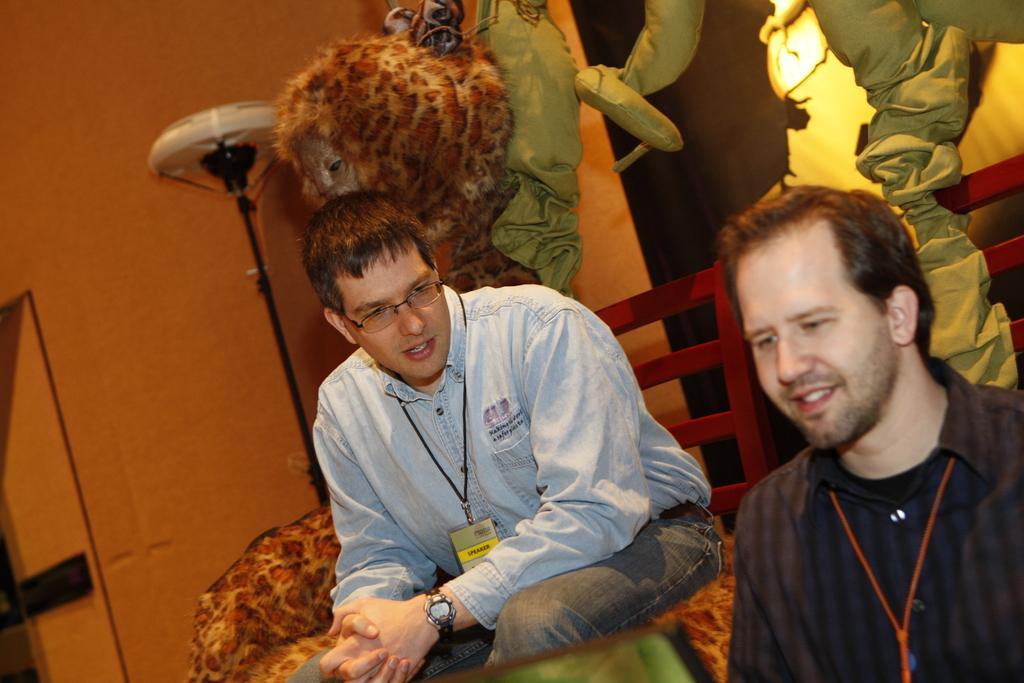Describe this image in one or two sentences. In this picture we can observe two men. One of them is wearing spectacles and both of them are wearing tags in their necks. We can observe a lamp here. In the background there is an orange color wall. 